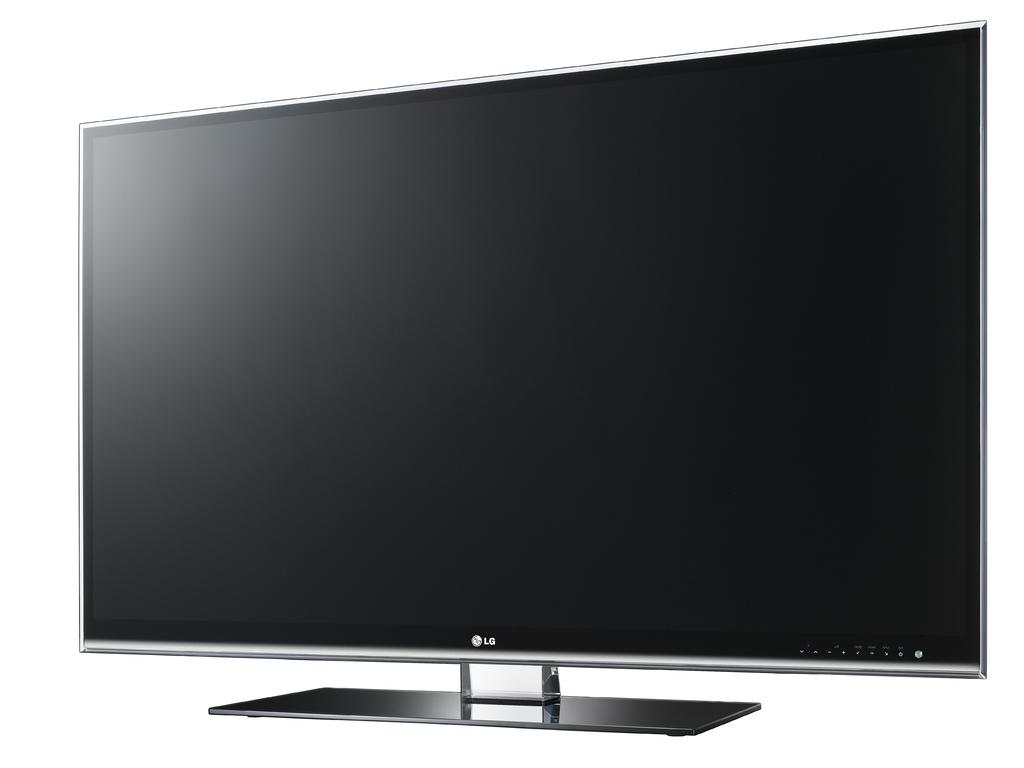<image>
Offer a succinct explanation of the picture presented. A large flat screen that says LG on the front is on a white background. 